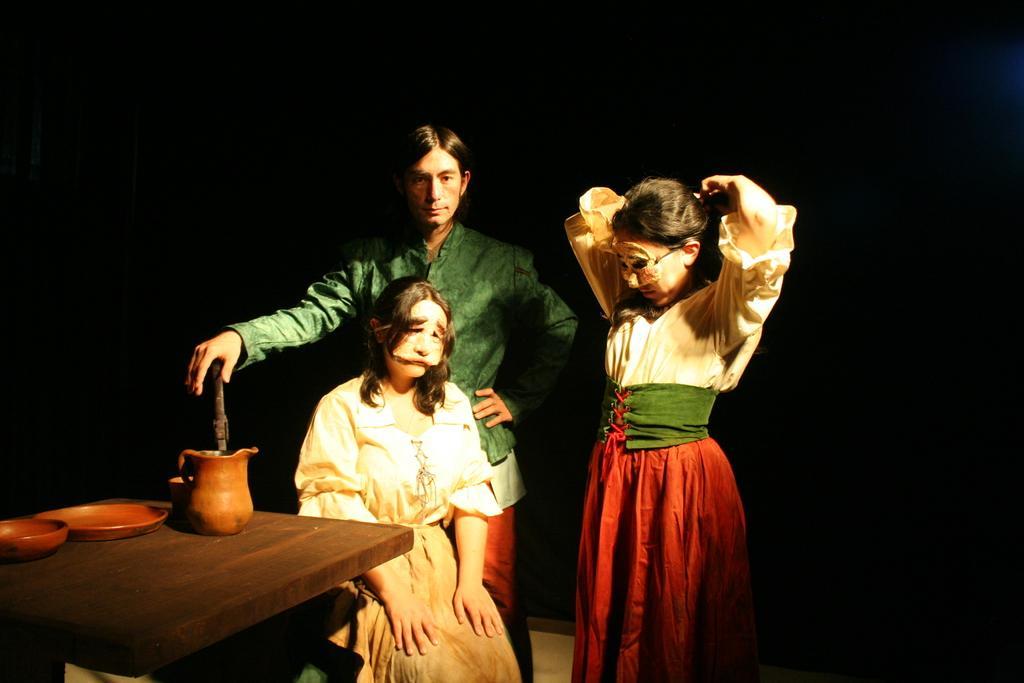How would you summarize this image in a sentence or two? In this image i can see a woman sitting on chair and 2 person standing behind her. I can see a table on which i can see a jar and 2 plates. 